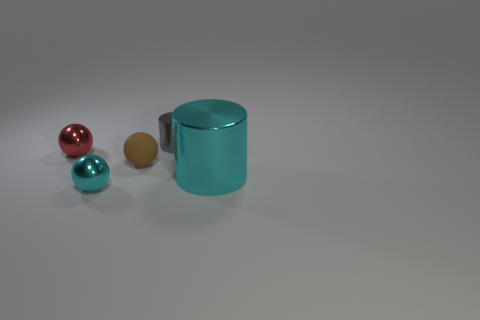There is a cyan object to the right of the small gray shiny thing; how big is it?
Give a very brief answer. Large. There is a metallic thing that is the same color as the big metallic cylinder; what shape is it?
Give a very brief answer. Sphere. Do the tiny cylinder and the thing in front of the cyan cylinder have the same material?
Your answer should be compact. Yes. What number of gray objects are in front of the object left of the cyan metal object to the left of the big cyan object?
Your response must be concise. 0. How many brown things are either large rubber spheres or rubber balls?
Provide a short and direct response. 1. The object that is behind the red ball has what shape?
Offer a terse response. Cylinder. There is a metallic cylinder that is the same size as the brown ball; what is its color?
Provide a succinct answer. Gray. There is a red thing; is its shape the same as the cyan object left of the small cylinder?
Your answer should be compact. Yes. What is the material of the ball that is in front of the cyan shiny thing that is to the right of the small metallic object that is behind the red metallic object?
Offer a very short reply. Metal. What number of large objects are either red metal blocks or cyan metal balls?
Your response must be concise. 0. 